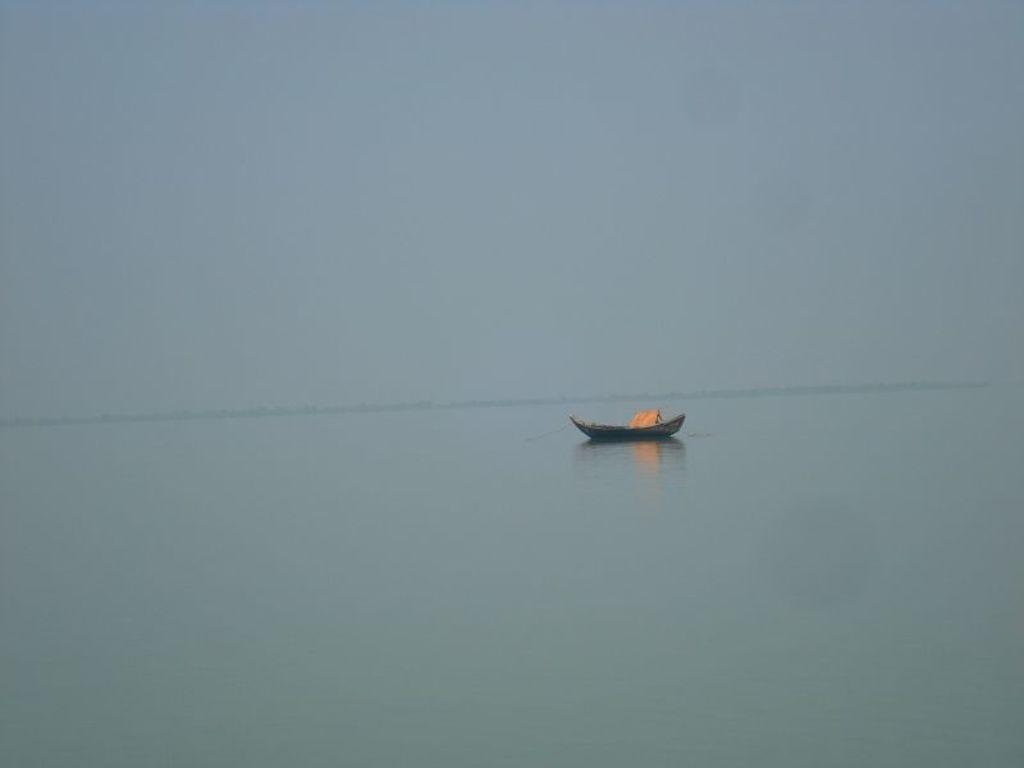Please provide a concise description of this image. In this image there is a river and we can see a boat on the river. In the background there is sky. 